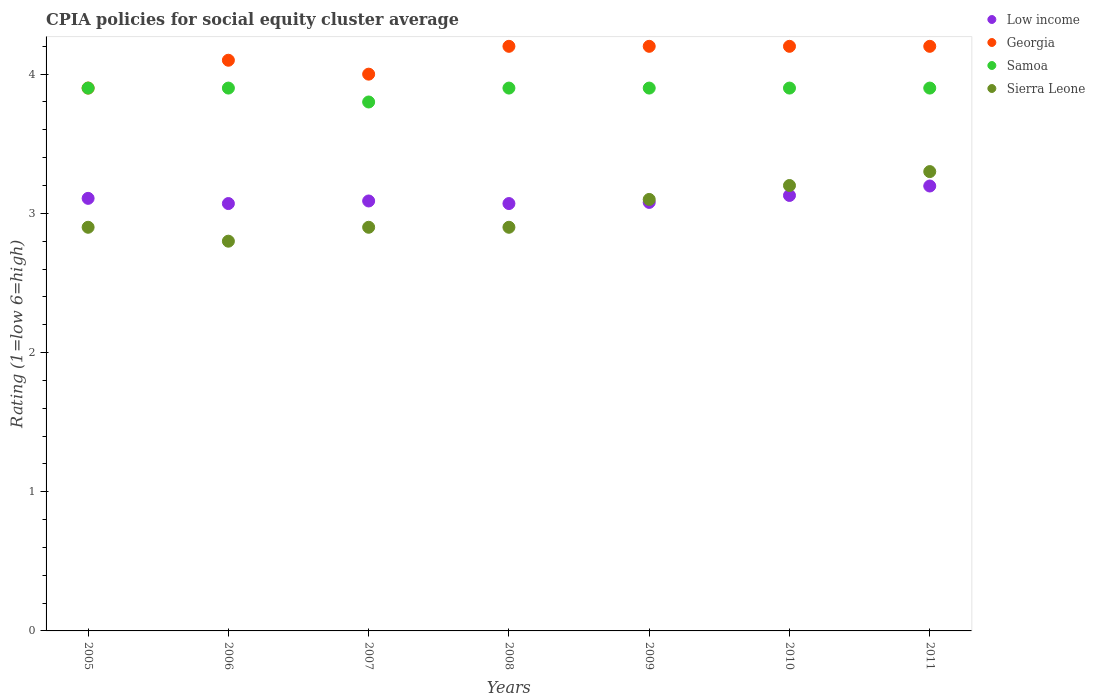How many different coloured dotlines are there?
Your answer should be very brief. 4. Is the number of dotlines equal to the number of legend labels?
Make the answer very short. Yes. Across all years, what is the maximum CPIA rating in Sierra Leone?
Keep it short and to the point. 3.3. Across all years, what is the minimum CPIA rating in Georgia?
Offer a very short reply. 3.9. What is the total CPIA rating in Low income in the graph?
Provide a succinct answer. 21.74. What is the difference between the CPIA rating in Sierra Leone in 2007 and that in 2011?
Provide a succinct answer. -0.4. What is the difference between the CPIA rating in Sierra Leone in 2005 and the CPIA rating in Samoa in 2008?
Provide a succinct answer. -1. What is the average CPIA rating in Low income per year?
Provide a succinct answer. 3.11. In the year 2005, what is the difference between the CPIA rating in Samoa and CPIA rating in Georgia?
Provide a short and direct response. 0. In how many years, is the CPIA rating in Sierra Leone greater than 0.8?
Your answer should be very brief. 7. What is the ratio of the CPIA rating in Low income in 2007 to that in 2011?
Offer a terse response. 0.97. What is the difference between the highest and the second highest CPIA rating in Georgia?
Your answer should be very brief. 0. What is the difference between the highest and the lowest CPIA rating in Samoa?
Your answer should be very brief. 0.1. Is it the case that in every year, the sum of the CPIA rating in Georgia and CPIA rating in Sierra Leone  is greater than the CPIA rating in Samoa?
Offer a terse response. Yes. Is the CPIA rating in Low income strictly greater than the CPIA rating in Georgia over the years?
Provide a succinct answer. No. Is the CPIA rating in Georgia strictly less than the CPIA rating in Samoa over the years?
Your answer should be very brief. No. What is the difference between two consecutive major ticks on the Y-axis?
Provide a short and direct response. 1. Does the graph contain any zero values?
Make the answer very short. No. Where does the legend appear in the graph?
Provide a succinct answer. Top right. How are the legend labels stacked?
Provide a short and direct response. Vertical. What is the title of the graph?
Offer a terse response. CPIA policies for social equity cluster average. Does "Solomon Islands" appear as one of the legend labels in the graph?
Your answer should be very brief. No. What is the label or title of the X-axis?
Your response must be concise. Years. What is the label or title of the Y-axis?
Your answer should be compact. Rating (1=low 6=high). What is the Rating (1=low 6=high) in Low income in 2005?
Ensure brevity in your answer.  3.11. What is the Rating (1=low 6=high) in Samoa in 2005?
Provide a succinct answer. 3.9. What is the Rating (1=low 6=high) of Sierra Leone in 2005?
Provide a succinct answer. 2.9. What is the Rating (1=low 6=high) of Low income in 2006?
Offer a very short reply. 3.07. What is the Rating (1=low 6=high) in Samoa in 2006?
Offer a very short reply. 3.9. What is the Rating (1=low 6=high) in Low income in 2007?
Provide a succinct answer. 3.09. What is the Rating (1=low 6=high) in Georgia in 2007?
Offer a very short reply. 4. What is the Rating (1=low 6=high) in Sierra Leone in 2007?
Your response must be concise. 2.9. What is the Rating (1=low 6=high) of Low income in 2008?
Your answer should be compact. 3.07. What is the Rating (1=low 6=high) of Low income in 2009?
Offer a terse response. 3.08. What is the Rating (1=low 6=high) in Georgia in 2009?
Keep it short and to the point. 4.2. What is the Rating (1=low 6=high) in Samoa in 2009?
Your response must be concise. 3.9. What is the Rating (1=low 6=high) in Low income in 2010?
Make the answer very short. 3.13. What is the Rating (1=low 6=high) of Samoa in 2010?
Give a very brief answer. 3.9. What is the Rating (1=low 6=high) in Low income in 2011?
Keep it short and to the point. 3.2. What is the Rating (1=low 6=high) in Samoa in 2011?
Provide a succinct answer. 3.9. What is the Rating (1=low 6=high) in Sierra Leone in 2011?
Your response must be concise. 3.3. Across all years, what is the maximum Rating (1=low 6=high) in Low income?
Provide a succinct answer. 3.2. Across all years, what is the maximum Rating (1=low 6=high) in Sierra Leone?
Give a very brief answer. 3.3. Across all years, what is the minimum Rating (1=low 6=high) in Low income?
Give a very brief answer. 3.07. Across all years, what is the minimum Rating (1=low 6=high) of Samoa?
Provide a short and direct response. 3.8. What is the total Rating (1=low 6=high) in Low income in the graph?
Ensure brevity in your answer.  21.74. What is the total Rating (1=low 6=high) of Georgia in the graph?
Your answer should be compact. 28.8. What is the total Rating (1=low 6=high) in Samoa in the graph?
Your answer should be compact. 27.2. What is the total Rating (1=low 6=high) in Sierra Leone in the graph?
Make the answer very short. 21.1. What is the difference between the Rating (1=low 6=high) in Low income in 2005 and that in 2006?
Offer a terse response. 0.04. What is the difference between the Rating (1=low 6=high) of Georgia in 2005 and that in 2006?
Ensure brevity in your answer.  -0.2. What is the difference between the Rating (1=low 6=high) in Samoa in 2005 and that in 2006?
Ensure brevity in your answer.  0. What is the difference between the Rating (1=low 6=high) in Sierra Leone in 2005 and that in 2006?
Your answer should be compact. 0.1. What is the difference between the Rating (1=low 6=high) of Low income in 2005 and that in 2007?
Offer a terse response. 0.02. What is the difference between the Rating (1=low 6=high) of Georgia in 2005 and that in 2007?
Your response must be concise. -0.1. What is the difference between the Rating (1=low 6=high) of Samoa in 2005 and that in 2007?
Ensure brevity in your answer.  0.1. What is the difference between the Rating (1=low 6=high) of Low income in 2005 and that in 2008?
Your answer should be compact. 0.04. What is the difference between the Rating (1=low 6=high) of Samoa in 2005 and that in 2008?
Ensure brevity in your answer.  0. What is the difference between the Rating (1=low 6=high) of Sierra Leone in 2005 and that in 2008?
Your answer should be very brief. 0. What is the difference between the Rating (1=low 6=high) of Low income in 2005 and that in 2009?
Your response must be concise. 0.03. What is the difference between the Rating (1=low 6=high) of Samoa in 2005 and that in 2009?
Make the answer very short. 0. What is the difference between the Rating (1=low 6=high) of Low income in 2005 and that in 2010?
Keep it short and to the point. -0.02. What is the difference between the Rating (1=low 6=high) of Georgia in 2005 and that in 2010?
Provide a short and direct response. -0.3. What is the difference between the Rating (1=low 6=high) in Samoa in 2005 and that in 2010?
Your answer should be very brief. 0. What is the difference between the Rating (1=low 6=high) of Sierra Leone in 2005 and that in 2010?
Keep it short and to the point. -0.3. What is the difference between the Rating (1=low 6=high) in Low income in 2005 and that in 2011?
Your answer should be very brief. -0.09. What is the difference between the Rating (1=low 6=high) of Georgia in 2005 and that in 2011?
Your answer should be compact. -0.3. What is the difference between the Rating (1=low 6=high) in Low income in 2006 and that in 2007?
Provide a short and direct response. -0.02. What is the difference between the Rating (1=low 6=high) in Samoa in 2006 and that in 2007?
Provide a succinct answer. 0.1. What is the difference between the Rating (1=low 6=high) in Sierra Leone in 2006 and that in 2007?
Give a very brief answer. -0.1. What is the difference between the Rating (1=low 6=high) of Georgia in 2006 and that in 2008?
Provide a short and direct response. -0.1. What is the difference between the Rating (1=low 6=high) in Samoa in 2006 and that in 2008?
Offer a terse response. 0. What is the difference between the Rating (1=low 6=high) in Low income in 2006 and that in 2009?
Provide a succinct answer. -0.01. What is the difference between the Rating (1=low 6=high) in Georgia in 2006 and that in 2009?
Keep it short and to the point. -0.1. What is the difference between the Rating (1=low 6=high) in Low income in 2006 and that in 2010?
Your response must be concise. -0.06. What is the difference between the Rating (1=low 6=high) in Samoa in 2006 and that in 2010?
Make the answer very short. 0. What is the difference between the Rating (1=low 6=high) of Sierra Leone in 2006 and that in 2010?
Give a very brief answer. -0.4. What is the difference between the Rating (1=low 6=high) of Low income in 2006 and that in 2011?
Make the answer very short. -0.13. What is the difference between the Rating (1=low 6=high) in Georgia in 2006 and that in 2011?
Your response must be concise. -0.1. What is the difference between the Rating (1=low 6=high) in Sierra Leone in 2006 and that in 2011?
Offer a terse response. -0.5. What is the difference between the Rating (1=low 6=high) in Low income in 2007 and that in 2008?
Your answer should be very brief. 0.02. What is the difference between the Rating (1=low 6=high) of Low income in 2007 and that in 2009?
Give a very brief answer. 0.01. What is the difference between the Rating (1=low 6=high) of Georgia in 2007 and that in 2009?
Your response must be concise. -0.2. What is the difference between the Rating (1=low 6=high) of Samoa in 2007 and that in 2009?
Ensure brevity in your answer.  -0.1. What is the difference between the Rating (1=low 6=high) in Sierra Leone in 2007 and that in 2009?
Your response must be concise. -0.2. What is the difference between the Rating (1=low 6=high) of Low income in 2007 and that in 2010?
Provide a succinct answer. -0.04. What is the difference between the Rating (1=low 6=high) in Samoa in 2007 and that in 2010?
Offer a terse response. -0.1. What is the difference between the Rating (1=low 6=high) of Sierra Leone in 2007 and that in 2010?
Offer a terse response. -0.3. What is the difference between the Rating (1=low 6=high) of Low income in 2007 and that in 2011?
Ensure brevity in your answer.  -0.11. What is the difference between the Rating (1=low 6=high) in Georgia in 2007 and that in 2011?
Offer a very short reply. -0.2. What is the difference between the Rating (1=low 6=high) in Low income in 2008 and that in 2009?
Keep it short and to the point. -0.01. What is the difference between the Rating (1=low 6=high) of Georgia in 2008 and that in 2009?
Your response must be concise. 0. What is the difference between the Rating (1=low 6=high) in Sierra Leone in 2008 and that in 2009?
Ensure brevity in your answer.  -0.2. What is the difference between the Rating (1=low 6=high) in Low income in 2008 and that in 2010?
Provide a short and direct response. -0.06. What is the difference between the Rating (1=low 6=high) in Sierra Leone in 2008 and that in 2010?
Your answer should be very brief. -0.3. What is the difference between the Rating (1=low 6=high) in Low income in 2008 and that in 2011?
Your answer should be very brief. -0.13. What is the difference between the Rating (1=low 6=high) of Samoa in 2008 and that in 2011?
Your answer should be compact. 0. What is the difference between the Rating (1=low 6=high) of Sierra Leone in 2008 and that in 2011?
Offer a terse response. -0.4. What is the difference between the Rating (1=low 6=high) of Low income in 2009 and that in 2010?
Your answer should be compact. -0.05. What is the difference between the Rating (1=low 6=high) in Georgia in 2009 and that in 2010?
Offer a very short reply. 0. What is the difference between the Rating (1=low 6=high) of Samoa in 2009 and that in 2010?
Provide a short and direct response. 0. What is the difference between the Rating (1=low 6=high) in Sierra Leone in 2009 and that in 2010?
Provide a succinct answer. -0.1. What is the difference between the Rating (1=low 6=high) in Low income in 2009 and that in 2011?
Your response must be concise. -0.12. What is the difference between the Rating (1=low 6=high) in Georgia in 2009 and that in 2011?
Offer a very short reply. 0. What is the difference between the Rating (1=low 6=high) in Low income in 2010 and that in 2011?
Offer a terse response. -0.07. What is the difference between the Rating (1=low 6=high) in Sierra Leone in 2010 and that in 2011?
Give a very brief answer. -0.1. What is the difference between the Rating (1=low 6=high) of Low income in 2005 and the Rating (1=low 6=high) of Georgia in 2006?
Your response must be concise. -0.99. What is the difference between the Rating (1=low 6=high) in Low income in 2005 and the Rating (1=low 6=high) in Samoa in 2006?
Offer a terse response. -0.79. What is the difference between the Rating (1=low 6=high) of Low income in 2005 and the Rating (1=low 6=high) of Sierra Leone in 2006?
Keep it short and to the point. 0.31. What is the difference between the Rating (1=low 6=high) of Georgia in 2005 and the Rating (1=low 6=high) of Sierra Leone in 2006?
Make the answer very short. 1.1. What is the difference between the Rating (1=low 6=high) of Low income in 2005 and the Rating (1=low 6=high) of Georgia in 2007?
Offer a terse response. -0.89. What is the difference between the Rating (1=low 6=high) of Low income in 2005 and the Rating (1=low 6=high) of Samoa in 2007?
Provide a short and direct response. -0.69. What is the difference between the Rating (1=low 6=high) of Low income in 2005 and the Rating (1=low 6=high) of Sierra Leone in 2007?
Keep it short and to the point. 0.21. What is the difference between the Rating (1=low 6=high) of Georgia in 2005 and the Rating (1=low 6=high) of Samoa in 2007?
Provide a succinct answer. 0.1. What is the difference between the Rating (1=low 6=high) of Low income in 2005 and the Rating (1=low 6=high) of Georgia in 2008?
Provide a succinct answer. -1.09. What is the difference between the Rating (1=low 6=high) of Low income in 2005 and the Rating (1=low 6=high) of Samoa in 2008?
Your answer should be compact. -0.79. What is the difference between the Rating (1=low 6=high) of Low income in 2005 and the Rating (1=low 6=high) of Sierra Leone in 2008?
Your response must be concise. 0.21. What is the difference between the Rating (1=low 6=high) of Georgia in 2005 and the Rating (1=low 6=high) of Samoa in 2008?
Keep it short and to the point. 0. What is the difference between the Rating (1=low 6=high) in Samoa in 2005 and the Rating (1=low 6=high) in Sierra Leone in 2008?
Your answer should be very brief. 1. What is the difference between the Rating (1=low 6=high) of Low income in 2005 and the Rating (1=low 6=high) of Georgia in 2009?
Provide a short and direct response. -1.09. What is the difference between the Rating (1=low 6=high) of Low income in 2005 and the Rating (1=low 6=high) of Samoa in 2009?
Your answer should be very brief. -0.79. What is the difference between the Rating (1=low 6=high) of Low income in 2005 and the Rating (1=low 6=high) of Sierra Leone in 2009?
Your answer should be compact. 0.01. What is the difference between the Rating (1=low 6=high) in Georgia in 2005 and the Rating (1=low 6=high) in Samoa in 2009?
Your answer should be compact. 0. What is the difference between the Rating (1=low 6=high) in Georgia in 2005 and the Rating (1=low 6=high) in Sierra Leone in 2009?
Your answer should be compact. 0.8. What is the difference between the Rating (1=low 6=high) in Low income in 2005 and the Rating (1=low 6=high) in Georgia in 2010?
Give a very brief answer. -1.09. What is the difference between the Rating (1=low 6=high) in Low income in 2005 and the Rating (1=low 6=high) in Samoa in 2010?
Your answer should be very brief. -0.79. What is the difference between the Rating (1=low 6=high) of Low income in 2005 and the Rating (1=low 6=high) of Sierra Leone in 2010?
Offer a very short reply. -0.09. What is the difference between the Rating (1=low 6=high) in Georgia in 2005 and the Rating (1=low 6=high) in Samoa in 2010?
Keep it short and to the point. 0. What is the difference between the Rating (1=low 6=high) in Georgia in 2005 and the Rating (1=low 6=high) in Sierra Leone in 2010?
Offer a terse response. 0.7. What is the difference between the Rating (1=low 6=high) of Samoa in 2005 and the Rating (1=low 6=high) of Sierra Leone in 2010?
Your response must be concise. 0.7. What is the difference between the Rating (1=low 6=high) of Low income in 2005 and the Rating (1=low 6=high) of Georgia in 2011?
Provide a succinct answer. -1.09. What is the difference between the Rating (1=low 6=high) in Low income in 2005 and the Rating (1=low 6=high) in Samoa in 2011?
Provide a succinct answer. -0.79. What is the difference between the Rating (1=low 6=high) in Low income in 2005 and the Rating (1=low 6=high) in Sierra Leone in 2011?
Your answer should be very brief. -0.19. What is the difference between the Rating (1=low 6=high) of Samoa in 2005 and the Rating (1=low 6=high) of Sierra Leone in 2011?
Your answer should be very brief. 0.6. What is the difference between the Rating (1=low 6=high) in Low income in 2006 and the Rating (1=low 6=high) in Georgia in 2007?
Your response must be concise. -0.93. What is the difference between the Rating (1=low 6=high) of Low income in 2006 and the Rating (1=low 6=high) of Samoa in 2007?
Your response must be concise. -0.73. What is the difference between the Rating (1=low 6=high) of Low income in 2006 and the Rating (1=low 6=high) of Sierra Leone in 2007?
Provide a short and direct response. 0.17. What is the difference between the Rating (1=low 6=high) of Georgia in 2006 and the Rating (1=low 6=high) of Sierra Leone in 2007?
Your answer should be compact. 1.2. What is the difference between the Rating (1=low 6=high) in Samoa in 2006 and the Rating (1=low 6=high) in Sierra Leone in 2007?
Offer a terse response. 1. What is the difference between the Rating (1=low 6=high) of Low income in 2006 and the Rating (1=low 6=high) of Georgia in 2008?
Provide a succinct answer. -1.13. What is the difference between the Rating (1=low 6=high) of Low income in 2006 and the Rating (1=low 6=high) of Samoa in 2008?
Keep it short and to the point. -0.83. What is the difference between the Rating (1=low 6=high) of Low income in 2006 and the Rating (1=low 6=high) of Sierra Leone in 2008?
Keep it short and to the point. 0.17. What is the difference between the Rating (1=low 6=high) in Georgia in 2006 and the Rating (1=low 6=high) in Samoa in 2008?
Your answer should be very brief. 0.2. What is the difference between the Rating (1=low 6=high) of Georgia in 2006 and the Rating (1=low 6=high) of Sierra Leone in 2008?
Keep it short and to the point. 1.2. What is the difference between the Rating (1=low 6=high) of Low income in 2006 and the Rating (1=low 6=high) of Georgia in 2009?
Offer a very short reply. -1.13. What is the difference between the Rating (1=low 6=high) of Low income in 2006 and the Rating (1=low 6=high) of Samoa in 2009?
Your answer should be very brief. -0.83. What is the difference between the Rating (1=low 6=high) of Low income in 2006 and the Rating (1=low 6=high) of Sierra Leone in 2009?
Give a very brief answer. -0.03. What is the difference between the Rating (1=low 6=high) in Georgia in 2006 and the Rating (1=low 6=high) in Samoa in 2009?
Provide a short and direct response. 0.2. What is the difference between the Rating (1=low 6=high) in Low income in 2006 and the Rating (1=low 6=high) in Georgia in 2010?
Offer a very short reply. -1.13. What is the difference between the Rating (1=low 6=high) in Low income in 2006 and the Rating (1=low 6=high) in Samoa in 2010?
Offer a very short reply. -0.83. What is the difference between the Rating (1=low 6=high) in Low income in 2006 and the Rating (1=low 6=high) in Sierra Leone in 2010?
Offer a very short reply. -0.13. What is the difference between the Rating (1=low 6=high) of Georgia in 2006 and the Rating (1=low 6=high) of Samoa in 2010?
Ensure brevity in your answer.  0.2. What is the difference between the Rating (1=low 6=high) in Low income in 2006 and the Rating (1=low 6=high) in Georgia in 2011?
Your answer should be compact. -1.13. What is the difference between the Rating (1=low 6=high) of Low income in 2006 and the Rating (1=low 6=high) of Samoa in 2011?
Give a very brief answer. -0.83. What is the difference between the Rating (1=low 6=high) in Low income in 2006 and the Rating (1=low 6=high) in Sierra Leone in 2011?
Offer a terse response. -0.23. What is the difference between the Rating (1=low 6=high) in Georgia in 2006 and the Rating (1=low 6=high) in Samoa in 2011?
Keep it short and to the point. 0.2. What is the difference between the Rating (1=low 6=high) in Samoa in 2006 and the Rating (1=low 6=high) in Sierra Leone in 2011?
Offer a very short reply. 0.6. What is the difference between the Rating (1=low 6=high) in Low income in 2007 and the Rating (1=low 6=high) in Georgia in 2008?
Provide a succinct answer. -1.11. What is the difference between the Rating (1=low 6=high) in Low income in 2007 and the Rating (1=low 6=high) in Samoa in 2008?
Offer a terse response. -0.81. What is the difference between the Rating (1=low 6=high) of Low income in 2007 and the Rating (1=low 6=high) of Sierra Leone in 2008?
Your response must be concise. 0.19. What is the difference between the Rating (1=low 6=high) of Georgia in 2007 and the Rating (1=low 6=high) of Samoa in 2008?
Provide a short and direct response. 0.1. What is the difference between the Rating (1=low 6=high) in Low income in 2007 and the Rating (1=low 6=high) in Georgia in 2009?
Provide a succinct answer. -1.11. What is the difference between the Rating (1=low 6=high) of Low income in 2007 and the Rating (1=low 6=high) of Samoa in 2009?
Give a very brief answer. -0.81. What is the difference between the Rating (1=low 6=high) in Low income in 2007 and the Rating (1=low 6=high) in Sierra Leone in 2009?
Ensure brevity in your answer.  -0.01. What is the difference between the Rating (1=low 6=high) of Low income in 2007 and the Rating (1=low 6=high) of Georgia in 2010?
Offer a terse response. -1.11. What is the difference between the Rating (1=low 6=high) in Low income in 2007 and the Rating (1=low 6=high) in Samoa in 2010?
Provide a succinct answer. -0.81. What is the difference between the Rating (1=low 6=high) of Low income in 2007 and the Rating (1=low 6=high) of Sierra Leone in 2010?
Make the answer very short. -0.11. What is the difference between the Rating (1=low 6=high) of Georgia in 2007 and the Rating (1=low 6=high) of Samoa in 2010?
Give a very brief answer. 0.1. What is the difference between the Rating (1=low 6=high) in Georgia in 2007 and the Rating (1=low 6=high) in Sierra Leone in 2010?
Offer a very short reply. 0.8. What is the difference between the Rating (1=low 6=high) of Low income in 2007 and the Rating (1=low 6=high) of Georgia in 2011?
Make the answer very short. -1.11. What is the difference between the Rating (1=low 6=high) in Low income in 2007 and the Rating (1=low 6=high) in Samoa in 2011?
Offer a terse response. -0.81. What is the difference between the Rating (1=low 6=high) in Low income in 2007 and the Rating (1=low 6=high) in Sierra Leone in 2011?
Make the answer very short. -0.21. What is the difference between the Rating (1=low 6=high) of Georgia in 2007 and the Rating (1=low 6=high) of Sierra Leone in 2011?
Offer a very short reply. 0.7. What is the difference between the Rating (1=low 6=high) in Samoa in 2007 and the Rating (1=low 6=high) in Sierra Leone in 2011?
Your response must be concise. 0.5. What is the difference between the Rating (1=low 6=high) in Low income in 2008 and the Rating (1=low 6=high) in Georgia in 2009?
Offer a terse response. -1.13. What is the difference between the Rating (1=low 6=high) of Low income in 2008 and the Rating (1=low 6=high) of Samoa in 2009?
Make the answer very short. -0.83. What is the difference between the Rating (1=low 6=high) in Low income in 2008 and the Rating (1=low 6=high) in Sierra Leone in 2009?
Offer a very short reply. -0.03. What is the difference between the Rating (1=low 6=high) in Georgia in 2008 and the Rating (1=low 6=high) in Samoa in 2009?
Keep it short and to the point. 0.3. What is the difference between the Rating (1=low 6=high) in Samoa in 2008 and the Rating (1=low 6=high) in Sierra Leone in 2009?
Give a very brief answer. 0.8. What is the difference between the Rating (1=low 6=high) of Low income in 2008 and the Rating (1=low 6=high) of Georgia in 2010?
Your answer should be very brief. -1.13. What is the difference between the Rating (1=low 6=high) of Low income in 2008 and the Rating (1=low 6=high) of Samoa in 2010?
Offer a terse response. -0.83. What is the difference between the Rating (1=low 6=high) of Low income in 2008 and the Rating (1=low 6=high) of Sierra Leone in 2010?
Keep it short and to the point. -0.13. What is the difference between the Rating (1=low 6=high) in Georgia in 2008 and the Rating (1=low 6=high) in Samoa in 2010?
Your answer should be compact. 0.3. What is the difference between the Rating (1=low 6=high) in Georgia in 2008 and the Rating (1=low 6=high) in Sierra Leone in 2010?
Provide a short and direct response. 1. What is the difference between the Rating (1=low 6=high) in Low income in 2008 and the Rating (1=low 6=high) in Georgia in 2011?
Your response must be concise. -1.13. What is the difference between the Rating (1=low 6=high) of Low income in 2008 and the Rating (1=low 6=high) of Samoa in 2011?
Give a very brief answer. -0.83. What is the difference between the Rating (1=low 6=high) of Low income in 2008 and the Rating (1=low 6=high) of Sierra Leone in 2011?
Keep it short and to the point. -0.23. What is the difference between the Rating (1=low 6=high) of Georgia in 2008 and the Rating (1=low 6=high) of Samoa in 2011?
Keep it short and to the point. 0.3. What is the difference between the Rating (1=low 6=high) in Georgia in 2008 and the Rating (1=low 6=high) in Sierra Leone in 2011?
Keep it short and to the point. 0.9. What is the difference between the Rating (1=low 6=high) in Samoa in 2008 and the Rating (1=low 6=high) in Sierra Leone in 2011?
Provide a succinct answer. 0.6. What is the difference between the Rating (1=low 6=high) of Low income in 2009 and the Rating (1=low 6=high) of Georgia in 2010?
Make the answer very short. -1.12. What is the difference between the Rating (1=low 6=high) of Low income in 2009 and the Rating (1=low 6=high) of Samoa in 2010?
Make the answer very short. -0.82. What is the difference between the Rating (1=low 6=high) of Low income in 2009 and the Rating (1=low 6=high) of Sierra Leone in 2010?
Your answer should be compact. -0.12. What is the difference between the Rating (1=low 6=high) of Georgia in 2009 and the Rating (1=low 6=high) of Samoa in 2010?
Your answer should be very brief. 0.3. What is the difference between the Rating (1=low 6=high) in Samoa in 2009 and the Rating (1=low 6=high) in Sierra Leone in 2010?
Your answer should be very brief. 0.7. What is the difference between the Rating (1=low 6=high) in Low income in 2009 and the Rating (1=low 6=high) in Georgia in 2011?
Your answer should be compact. -1.12. What is the difference between the Rating (1=low 6=high) of Low income in 2009 and the Rating (1=low 6=high) of Samoa in 2011?
Keep it short and to the point. -0.82. What is the difference between the Rating (1=low 6=high) in Low income in 2009 and the Rating (1=low 6=high) in Sierra Leone in 2011?
Keep it short and to the point. -0.22. What is the difference between the Rating (1=low 6=high) of Georgia in 2009 and the Rating (1=low 6=high) of Samoa in 2011?
Your answer should be very brief. 0.3. What is the difference between the Rating (1=low 6=high) of Samoa in 2009 and the Rating (1=low 6=high) of Sierra Leone in 2011?
Your answer should be compact. 0.6. What is the difference between the Rating (1=low 6=high) of Low income in 2010 and the Rating (1=low 6=high) of Georgia in 2011?
Make the answer very short. -1.07. What is the difference between the Rating (1=low 6=high) of Low income in 2010 and the Rating (1=low 6=high) of Samoa in 2011?
Offer a very short reply. -0.77. What is the difference between the Rating (1=low 6=high) in Low income in 2010 and the Rating (1=low 6=high) in Sierra Leone in 2011?
Make the answer very short. -0.17. What is the difference between the Rating (1=low 6=high) of Georgia in 2010 and the Rating (1=low 6=high) of Samoa in 2011?
Ensure brevity in your answer.  0.3. What is the difference between the Rating (1=low 6=high) of Georgia in 2010 and the Rating (1=low 6=high) of Sierra Leone in 2011?
Your answer should be very brief. 0.9. What is the difference between the Rating (1=low 6=high) of Samoa in 2010 and the Rating (1=low 6=high) of Sierra Leone in 2011?
Your response must be concise. 0.6. What is the average Rating (1=low 6=high) of Low income per year?
Make the answer very short. 3.11. What is the average Rating (1=low 6=high) of Georgia per year?
Offer a very short reply. 4.11. What is the average Rating (1=low 6=high) in Samoa per year?
Offer a very short reply. 3.89. What is the average Rating (1=low 6=high) in Sierra Leone per year?
Offer a terse response. 3.01. In the year 2005, what is the difference between the Rating (1=low 6=high) of Low income and Rating (1=low 6=high) of Georgia?
Make the answer very short. -0.79. In the year 2005, what is the difference between the Rating (1=low 6=high) in Low income and Rating (1=low 6=high) in Samoa?
Offer a terse response. -0.79. In the year 2005, what is the difference between the Rating (1=low 6=high) in Low income and Rating (1=low 6=high) in Sierra Leone?
Keep it short and to the point. 0.21. In the year 2005, what is the difference between the Rating (1=low 6=high) of Samoa and Rating (1=low 6=high) of Sierra Leone?
Ensure brevity in your answer.  1. In the year 2006, what is the difference between the Rating (1=low 6=high) of Low income and Rating (1=low 6=high) of Georgia?
Offer a very short reply. -1.03. In the year 2006, what is the difference between the Rating (1=low 6=high) in Low income and Rating (1=low 6=high) in Samoa?
Your response must be concise. -0.83. In the year 2006, what is the difference between the Rating (1=low 6=high) of Low income and Rating (1=low 6=high) of Sierra Leone?
Ensure brevity in your answer.  0.27. In the year 2006, what is the difference between the Rating (1=low 6=high) in Georgia and Rating (1=low 6=high) in Samoa?
Offer a very short reply. 0.2. In the year 2006, what is the difference between the Rating (1=low 6=high) of Samoa and Rating (1=low 6=high) of Sierra Leone?
Offer a very short reply. 1.1. In the year 2007, what is the difference between the Rating (1=low 6=high) of Low income and Rating (1=low 6=high) of Georgia?
Offer a terse response. -0.91. In the year 2007, what is the difference between the Rating (1=low 6=high) of Low income and Rating (1=low 6=high) of Samoa?
Offer a terse response. -0.71. In the year 2007, what is the difference between the Rating (1=low 6=high) of Low income and Rating (1=low 6=high) of Sierra Leone?
Your answer should be very brief. 0.19. In the year 2008, what is the difference between the Rating (1=low 6=high) of Low income and Rating (1=low 6=high) of Georgia?
Offer a terse response. -1.13. In the year 2008, what is the difference between the Rating (1=low 6=high) in Low income and Rating (1=low 6=high) in Samoa?
Give a very brief answer. -0.83. In the year 2008, what is the difference between the Rating (1=low 6=high) of Low income and Rating (1=low 6=high) of Sierra Leone?
Offer a very short reply. 0.17. In the year 2008, what is the difference between the Rating (1=low 6=high) of Samoa and Rating (1=low 6=high) of Sierra Leone?
Keep it short and to the point. 1. In the year 2009, what is the difference between the Rating (1=low 6=high) of Low income and Rating (1=low 6=high) of Georgia?
Make the answer very short. -1.12. In the year 2009, what is the difference between the Rating (1=low 6=high) in Low income and Rating (1=low 6=high) in Samoa?
Offer a very short reply. -0.82. In the year 2009, what is the difference between the Rating (1=low 6=high) in Low income and Rating (1=low 6=high) in Sierra Leone?
Ensure brevity in your answer.  -0.02. In the year 2009, what is the difference between the Rating (1=low 6=high) of Georgia and Rating (1=low 6=high) of Sierra Leone?
Make the answer very short. 1.1. In the year 2010, what is the difference between the Rating (1=low 6=high) of Low income and Rating (1=low 6=high) of Georgia?
Ensure brevity in your answer.  -1.07. In the year 2010, what is the difference between the Rating (1=low 6=high) in Low income and Rating (1=low 6=high) in Samoa?
Provide a succinct answer. -0.77. In the year 2010, what is the difference between the Rating (1=low 6=high) of Low income and Rating (1=low 6=high) of Sierra Leone?
Your response must be concise. -0.07. In the year 2010, what is the difference between the Rating (1=low 6=high) in Georgia and Rating (1=low 6=high) in Sierra Leone?
Ensure brevity in your answer.  1. In the year 2011, what is the difference between the Rating (1=low 6=high) in Low income and Rating (1=low 6=high) in Georgia?
Make the answer very short. -1. In the year 2011, what is the difference between the Rating (1=low 6=high) of Low income and Rating (1=low 6=high) of Samoa?
Your answer should be compact. -0.7. In the year 2011, what is the difference between the Rating (1=low 6=high) in Low income and Rating (1=low 6=high) in Sierra Leone?
Your answer should be very brief. -0.1. In the year 2011, what is the difference between the Rating (1=low 6=high) in Georgia and Rating (1=low 6=high) in Samoa?
Offer a terse response. 0.3. In the year 2011, what is the difference between the Rating (1=low 6=high) in Georgia and Rating (1=low 6=high) in Sierra Leone?
Your answer should be compact. 0.9. In the year 2011, what is the difference between the Rating (1=low 6=high) in Samoa and Rating (1=low 6=high) in Sierra Leone?
Make the answer very short. 0.6. What is the ratio of the Rating (1=low 6=high) of Low income in 2005 to that in 2006?
Your response must be concise. 1.01. What is the ratio of the Rating (1=low 6=high) in Georgia in 2005 to that in 2006?
Offer a very short reply. 0.95. What is the ratio of the Rating (1=low 6=high) in Samoa in 2005 to that in 2006?
Offer a terse response. 1. What is the ratio of the Rating (1=low 6=high) in Sierra Leone in 2005 to that in 2006?
Offer a very short reply. 1.04. What is the ratio of the Rating (1=low 6=high) of Low income in 2005 to that in 2007?
Offer a terse response. 1.01. What is the ratio of the Rating (1=low 6=high) of Georgia in 2005 to that in 2007?
Your answer should be compact. 0.97. What is the ratio of the Rating (1=low 6=high) in Samoa in 2005 to that in 2007?
Make the answer very short. 1.03. What is the ratio of the Rating (1=low 6=high) of Low income in 2005 to that in 2008?
Offer a terse response. 1.01. What is the ratio of the Rating (1=low 6=high) in Georgia in 2005 to that in 2008?
Your answer should be compact. 0.93. What is the ratio of the Rating (1=low 6=high) of Low income in 2005 to that in 2009?
Offer a very short reply. 1.01. What is the ratio of the Rating (1=low 6=high) of Samoa in 2005 to that in 2009?
Ensure brevity in your answer.  1. What is the ratio of the Rating (1=low 6=high) in Sierra Leone in 2005 to that in 2009?
Give a very brief answer. 0.94. What is the ratio of the Rating (1=low 6=high) of Sierra Leone in 2005 to that in 2010?
Keep it short and to the point. 0.91. What is the ratio of the Rating (1=low 6=high) of Low income in 2005 to that in 2011?
Provide a short and direct response. 0.97. What is the ratio of the Rating (1=low 6=high) of Samoa in 2005 to that in 2011?
Offer a terse response. 1. What is the ratio of the Rating (1=low 6=high) in Sierra Leone in 2005 to that in 2011?
Ensure brevity in your answer.  0.88. What is the ratio of the Rating (1=low 6=high) of Georgia in 2006 to that in 2007?
Provide a short and direct response. 1.02. What is the ratio of the Rating (1=low 6=high) of Samoa in 2006 to that in 2007?
Your answer should be very brief. 1.03. What is the ratio of the Rating (1=low 6=high) of Sierra Leone in 2006 to that in 2007?
Your answer should be compact. 0.97. What is the ratio of the Rating (1=low 6=high) in Georgia in 2006 to that in 2008?
Ensure brevity in your answer.  0.98. What is the ratio of the Rating (1=low 6=high) of Sierra Leone in 2006 to that in 2008?
Your answer should be compact. 0.97. What is the ratio of the Rating (1=low 6=high) of Low income in 2006 to that in 2009?
Make the answer very short. 1. What is the ratio of the Rating (1=low 6=high) of Georgia in 2006 to that in 2009?
Give a very brief answer. 0.98. What is the ratio of the Rating (1=low 6=high) in Sierra Leone in 2006 to that in 2009?
Keep it short and to the point. 0.9. What is the ratio of the Rating (1=low 6=high) of Low income in 2006 to that in 2010?
Offer a terse response. 0.98. What is the ratio of the Rating (1=low 6=high) in Georgia in 2006 to that in 2010?
Offer a terse response. 0.98. What is the ratio of the Rating (1=low 6=high) in Low income in 2006 to that in 2011?
Make the answer very short. 0.96. What is the ratio of the Rating (1=low 6=high) in Georgia in 2006 to that in 2011?
Provide a short and direct response. 0.98. What is the ratio of the Rating (1=low 6=high) of Sierra Leone in 2006 to that in 2011?
Your answer should be compact. 0.85. What is the ratio of the Rating (1=low 6=high) in Low income in 2007 to that in 2008?
Offer a very short reply. 1.01. What is the ratio of the Rating (1=low 6=high) in Samoa in 2007 to that in 2008?
Provide a short and direct response. 0.97. What is the ratio of the Rating (1=low 6=high) of Sierra Leone in 2007 to that in 2008?
Make the answer very short. 1. What is the ratio of the Rating (1=low 6=high) of Samoa in 2007 to that in 2009?
Keep it short and to the point. 0.97. What is the ratio of the Rating (1=low 6=high) in Sierra Leone in 2007 to that in 2009?
Offer a terse response. 0.94. What is the ratio of the Rating (1=low 6=high) in Low income in 2007 to that in 2010?
Provide a short and direct response. 0.99. What is the ratio of the Rating (1=low 6=high) of Samoa in 2007 to that in 2010?
Your response must be concise. 0.97. What is the ratio of the Rating (1=low 6=high) in Sierra Leone in 2007 to that in 2010?
Offer a terse response. 0.91. What is the ratio of the Rating (1=low 6=high) of Low income in 2007 to that in 2011?
Your answer should be very brief. 0.97. What is the ratio of the Rating (1=low 6=high) of Samoa in 2007 to that in 2011?
Your response must be concise. 0.97. What is the ratio of the Rating (1=low 6=high) in Sierra Leone in 2007 to that in 2011?
Make the answer very short. 0.88. What is the ratio of the Rating (1=low 6=high) in Low income in 2008 to that in 2009?
Offer a very short reply. 1. What is the ratio of the Rating (1=low 6=high) in Georgia in 2008 to that in 2009?
Your answer should be very brief. 1. What is the ratio of the Rating (1=low 6=high) in Samoa in 2008 to that in 2009?
Offer a very short reply. 1. What is the ratio of the Rating (1=low 6=high) of Sierra Leone in 2008 to that in 2009?
Offer a terse response. 0.94. What is the ratio of the Rating (1=low 6=high) in Low income in 2008 to that in 2010?
Provide a short and direct response. 0.98. What is the ratio of the Rating (1=low 6=high) of Sierra Leone in 2008 to that in 2010?
Ensure brevity in your answer.  0.91. What is the ratio of the Rating (1=low 6=high) in Low income in 2008 to that in 2011?
Your answer should be very brief. 0.96. What is the ratio of the Rating (1=low 6=high) in Georgia in 2008 to that in 2011?
Offer a terse response. 1. What is the ratio of the Rating (1=low 6=high) in Sierra Leone in 2008 to that in 2011?
Your answer should be compact. 0.88. What is the ratio of the Rating (1=low 6=high) of Sierra Leone in 2009 to that in 2010?
Your response must be concise. 0.97. What is the ratio of the Rating (1=low 6=high) of Low income in 2009 to that in 2011?
Offer a terse response. 0.96. What is the ratio of the Rating (1=low 6=high) of Sierra Leone in 2009 to that in 2011?
Provide a succinct answer. 0.94. What is the ratio of the Rating (1=low 6=high) in Low income in 2010 to that in 2011?
Give a very brief answer. 0.98. What is the ratio of the Rating (1=low 6=high) in Georgia in 2010 to that in 2011?
Offer a very short reply. 1. What is the ratio of the Rating (1=low 6=high) of Samoa in 2010 to that in 2011?
Ensure brevity in your answer.  1. What is the ratio of the Rating (1=low 6=high) of Sierra Leone in 2010 to that in 2011?
Keep it short and to the point. 0.97. What is the difference between the highest and the second highest Rating (1=low 6=high) in Low income?
Make the answer very short. 0.07. What is the difference between the highest and the second highest Rating (1=low 6=high) in Samoa?
Your response must be concise. 0. What is the difference between the highest and the second highest Rating (1=low 6=high) in Sierra Leone?
Your answer should be very brief. 0.1. What is the difference between the highest and the lowest Rating (1=low 6=high) in Low income?
Your answer should be compact. 0.13. What is the difference between the highest and the lowest Rating (1=low 6=high) in Sierra Leone?
Provide a succinct answer. 0.5. 